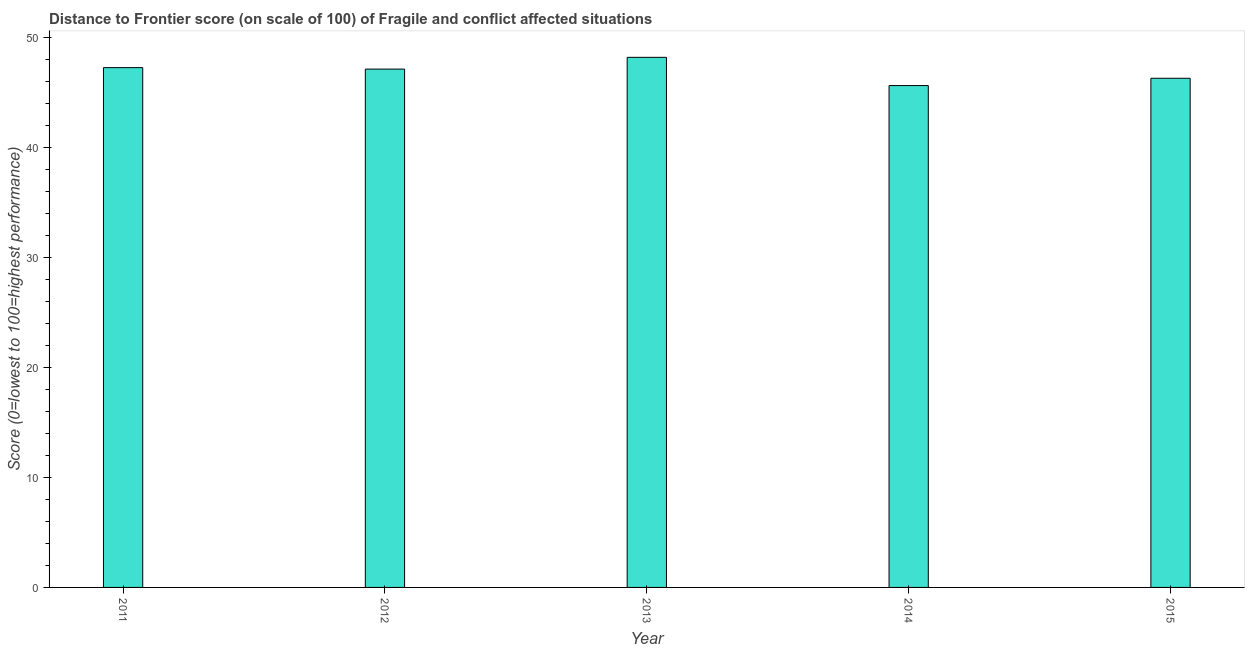Does the graph contain any zero values?
Your response must be concise. No. What is the title of the graph?
Your response must be concise. Distance to Frontier score (on scale of 100) of Fragile and conflict affected situations. What is the label or title of the X-axis?
Keep it short and to the point. Year. What is the label or title of the Y-axis?
Your answer should be very brief. Score (0=lowest to 100=highest performance). What is the distance to frontier score in 2012?
Provide a succinct answer. 47.11. Across all years, what is the maximum distance to frontier score?
Your answer should be compact. 48.18. Across all years, what is the minimum distance to frontier score?
Provide a succinct answer. 45.62. In which year was the distance to frontier score maximum?
Give a very brief answer. 2013. What is the sum of the distance to frontier score?
Provide a succinct answer. 234.43. What is the difference between the distance to frontier score in 2012 and 2013?
Offer a very short reply. -1.07. What is the average distance to frontier score per year?
Ensure brevity in your answer.  46.89. What is the median distance to frontier score?
Provide a succinct answer. 47.11. What is the ratio of the distance to frontier score in 2011 to that in 2014?
Ensure brevity in your answer.  1.04. Is the distance to frontier score in 2013 less than that in 2015?
Provide a short and direct response. No. Is the difference between the distance to frontier score in 2011 and 2013 greater than the difference between any two years?
Give a very brief answer. No. What is the difference between the highest and the second highest distance to frontier score?
Your response must be concise. 0.94. Is the sum of the distance to frontier score in 2011 and 2012 greater than the maximum distance to frontier score across all years?
Offer a terse response. Yes. What is the difference between the highest and the lowest distance to frontier score?
Give a very brief answer. 2.57. In how many years, is the distance to frontier score greater than the average distance to frontier score taken over all years?
Your answer should be compact. 3. Are all the bars in the graph horizontal?
Make the answer very short. No. What is the Score (0=lowest to 100=highest performance) in 2011?
Your answer should be very brief. 47.25. What is the Score (0=lowest to 100=highest performance) in 2012?
Ensure brevity in your answer.  47.11. What is the Score (0=lowest to 100=highest performance) of 2013?
Your answer should be compact. 48.18. What is the Score (0=lowest to 100=highest performance) in 2014?
Offer a very short reply. 45.62. What is the Score (0=lowest to 100=highest performance) in 2015?
Keep it short and to the point. 46.28. What is the difference between the Score (0=lowest to 100=highest performance) in 2011 and 2012?
Your answer should be compact. 0.13. What is the difference between the Score (0=lowest to 100=highest performance) in 2011 and 2013?
Offer a terse response. -0.94. What is the difference between the Score (0=lowest to 100=highest performance) in 2011 and 2014?
Your response must be concise. 1.63. What is the difference between the Score (0=lowest to 100=highest performance) in 2011 and 2015?
Provide a succinct answer. 0.97. What is the difference between the Score (0=lowest to 100=highest performance) in 2012 and 2013?
Provide a short and direct response. -1.07. What is the difference between the Score (0=lowest to 100=highest performance) in 2012 and 2014?
Offer a very short reply. 1.5. What is the difference between the Score (0=lowest to 100=highest performance) in 2012 and 2015?
Offer a very short reply. 0.83. What is the difference between the Score (0=lowest to 100=highest performance) in 2013 and 2014?
Ensure brevity in your answer.  2.57. What is the difference between the Score (0=lowest to 100=highest performance) in 2013 and 2015?
Ensure brevity in your answer.  1.9. What is the difference between the Score (0=lowest to 100=highest performance) in 2014 and 2015?
Make the answer very short. -0.66. What is the ratio of the Score (0=lowest to 100=highest performance) in 2011 to that in 2013?
Make the answer very short. 0.98. What is the ratio of the Score (0=lowest to 100=highest performance) in 2011 to that in 2014?
Ensure brevity in your answer.  1.04. What is the ratio of the Score (0=lowest to 100=highest performance) in 2012 to that in 2013?
Ensure brevity in your answer.  0.98. What is the ratio of the Score (0=lowest to 100=highest performance) in 2012 to that in 2014?
Offer a very short reply. 1.03. What is the ratio of the Score (0=lowest to 100=highest performance) in 2013 to that in 2014?
Provide a short and direct response. 1.06. What is the ratio of the Score (0=lowest to 100=highest performance) in 2013 to that in 2015?
Provide a succinct answer. 1.04. What is the ratio of the Score (0=lowest to 100=highest performance) in 2014 to that in 2015?
Make the answer very short. 0.99. 